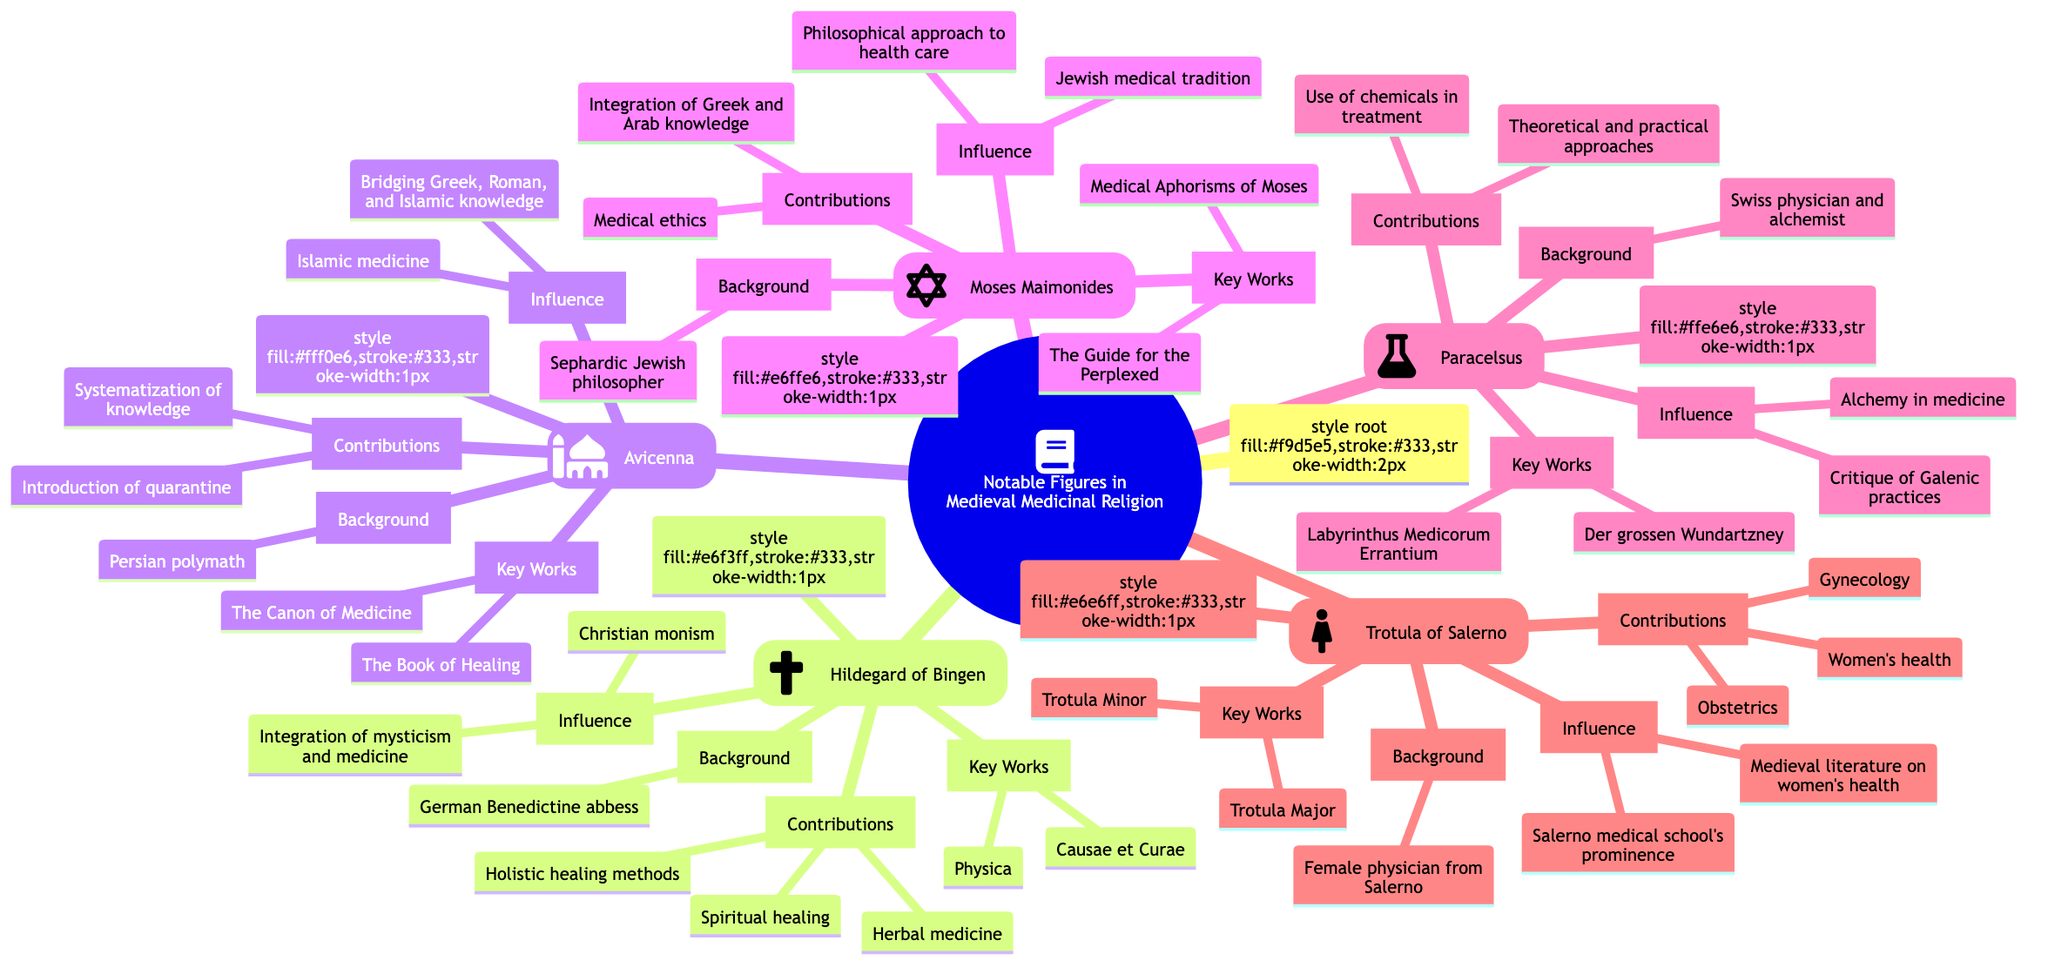What are the key works of Avicenna? By examining the node "Avicenna," the key works are listed directly under the "Key Works" section. They include "The Book of Healing" and "The Canon of Medicine."
Answer: The Book of Healing, The Canon of Medicine Who is considered the first female gynecologist? Looking at the node for "Trotula of Salerno," she is identified as the first female gynecologist according to the background information provided.
Answer: Trotula of Salerno What contribution did Hildegard of Bingen make to herbal medicine? Checking the contributions listed under "Hildegard of Bingen," herbal medicine is explicitly mentioned as one of her contributions to the field of medicinal religion.
Answer: Herbal medicine How many notable figures are listed in the mind map? The root node outlines five distinct notable figures: Hildegard of Bingen, Avicenna, Moses Maimonides, Paracelsus, and Trotula of Salerno.
Answer: Five Which notable figure integrated Greek and Arab medical knowledge with Jewish thought? By referencing the contributions of "Moses Maimonides," it states he integrated Greek and Arab medical knowledge with Jewish thought, showcasing his influence in the field.
Answer: Moses Maimonides What influence did Paracelsus have in medicine? Paracelsus is noted for his influence related to alchemy in medicine and his critique of traditional Galenic medical practices, detailed under the influence section.
Answer: Alchemy in medicine, critique of Galenic practices Which notable figure's key work includes "Physica"? In the node for "Hildegard of Bingen," "Physica" appears under the "Key Works" section, identifying her as the figure associated with this work.
Answer: Hildegard of Bingen What is the background of Avicenna? By reviewing the node for Avicenna, he is described as a Persian polymath, providing a concise answer to his background in the diagram.
Answer: Persian polymath What was Trotula of Salerno's focus in her contributions? The contributions listed under Trotula of Salerno include women's health, gynecology, and obstetrics, indicating her focus.
Answer: Women's health, gynecology, obstetrics 